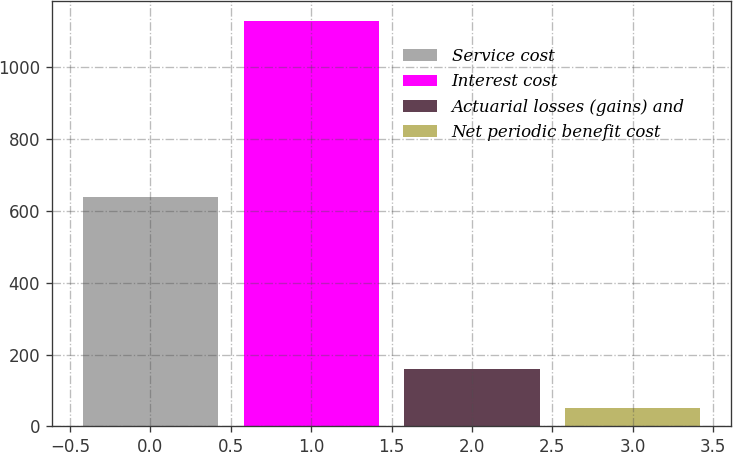<chart> <loc_0><loc_0><loc_500><loc_500><bar_chart><fcel>Service cost<fcel>Interest cost<fcel>Actuarial losses (gains) and<fcel>Net periodic benefit cost<nl><fcel>638<fcel>1128<fcel>159.6<fcel>52<nl></chart> 